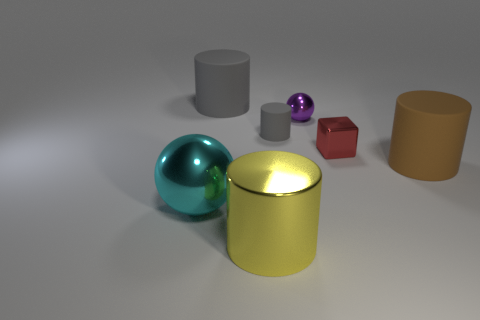Subtract 1 cylinders. How many cylinders are left? 3 Add 1 brown objects. How many objects exist? 8 Subtract all cubes. How many objects are left? 6 Add 2 tiny red blocks. How many tiny red blocks exist? 3 Subtract 0 brown balls. How many objects are left? 7 Subtract all big yellow cylinders. Subtract all large gray rubber things. How many objects are left? 5 Add 3 yellow objects. How many yellow objects are left? 4 